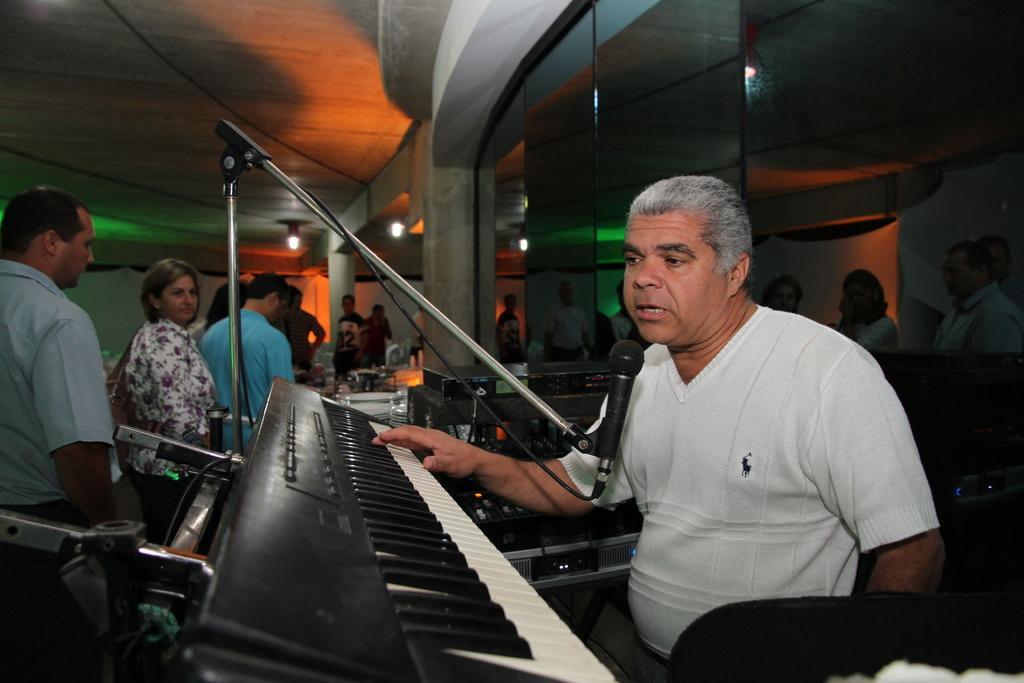How would you summarize this image in a sentence or two? In this image i can see a man wearing white shirt singing in front of a micro phone, playing a piano at left there are few other persons standing, a person standing at front wearing a blue shirt, a woman wearing a white shirt and a man wearing a white shirt, at right there is a glass window at the back ground there are few other persons standing at the top there is a light. 